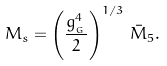Convert formula to latex. <formula><loc_0><loc_0><loc_500><loc_500>M _ { s } = \left ( \frac { g _ { _ { G } } ^ { 4 } } { 2 } \right ) ^ { 1 / 3 } \, \bar { M } _ { 5 } .</formula> 